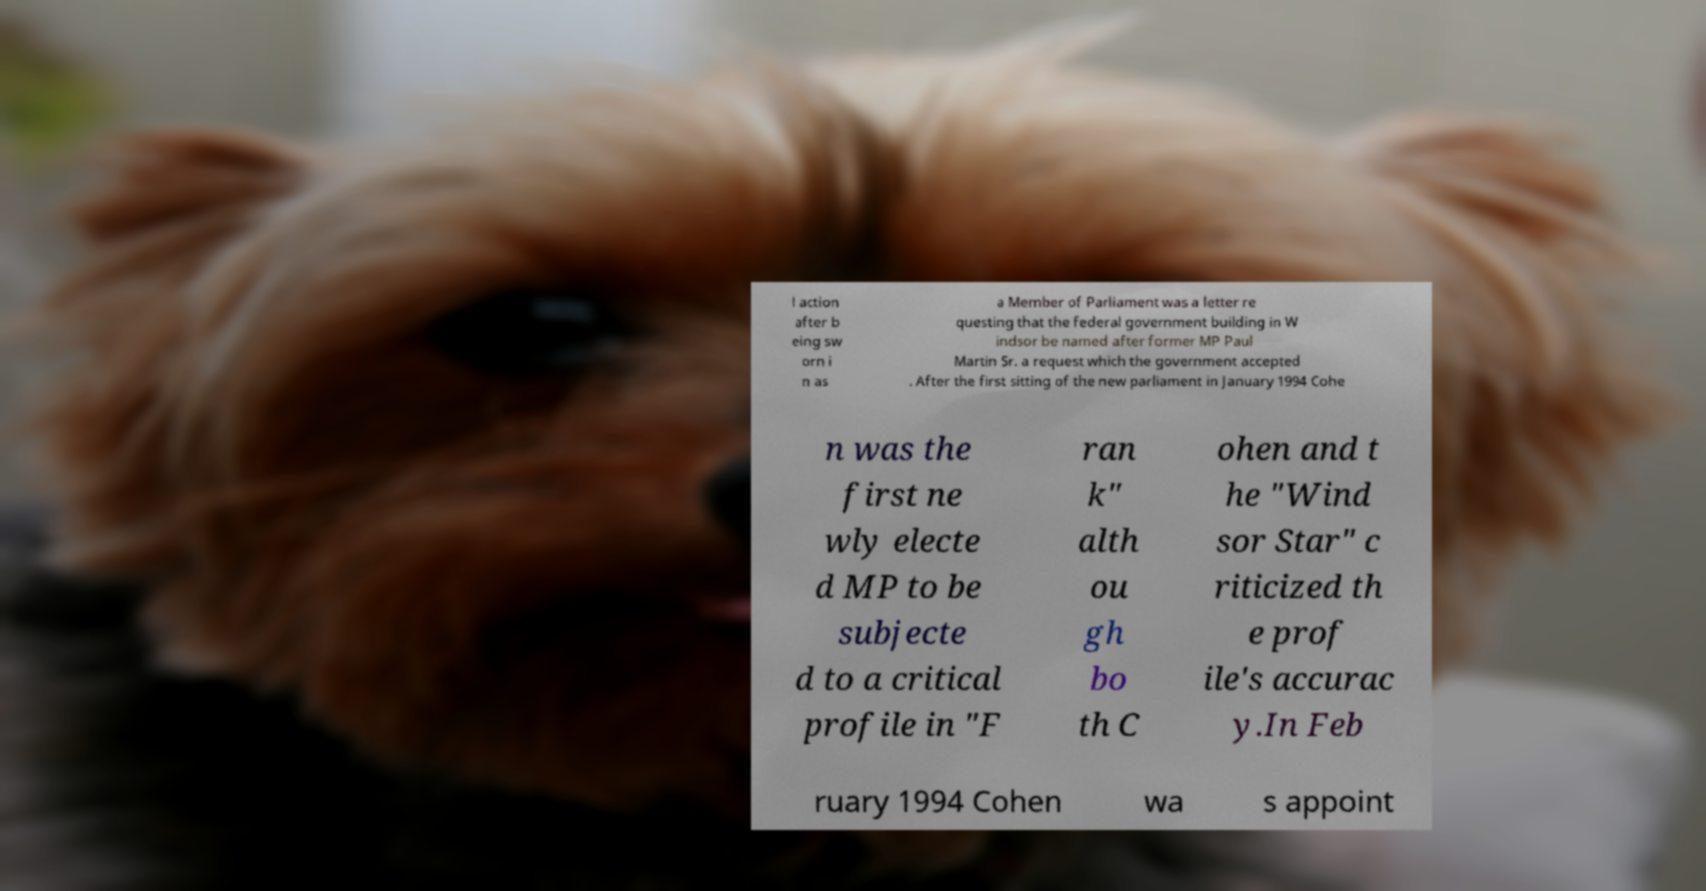I need the written content from this picture converted into text. Can you do that? l action after b eing sw orn i n as a Member of Parliament was a letter re questing that the federal government building in W indsor be named after former MP Paul Martin Sr. a request which the government accepted . After the first sitting of the new parliament in January 1994 Cohe n was the first ne wly electe d MP to be subjecte d to a critical profile in "F ran k" alth ou gh bo th C ohen and t he "Wind sor Star" c riticized th e prof ile's accurac y.In Feb ruary 1994 Cohen wa s appoint 